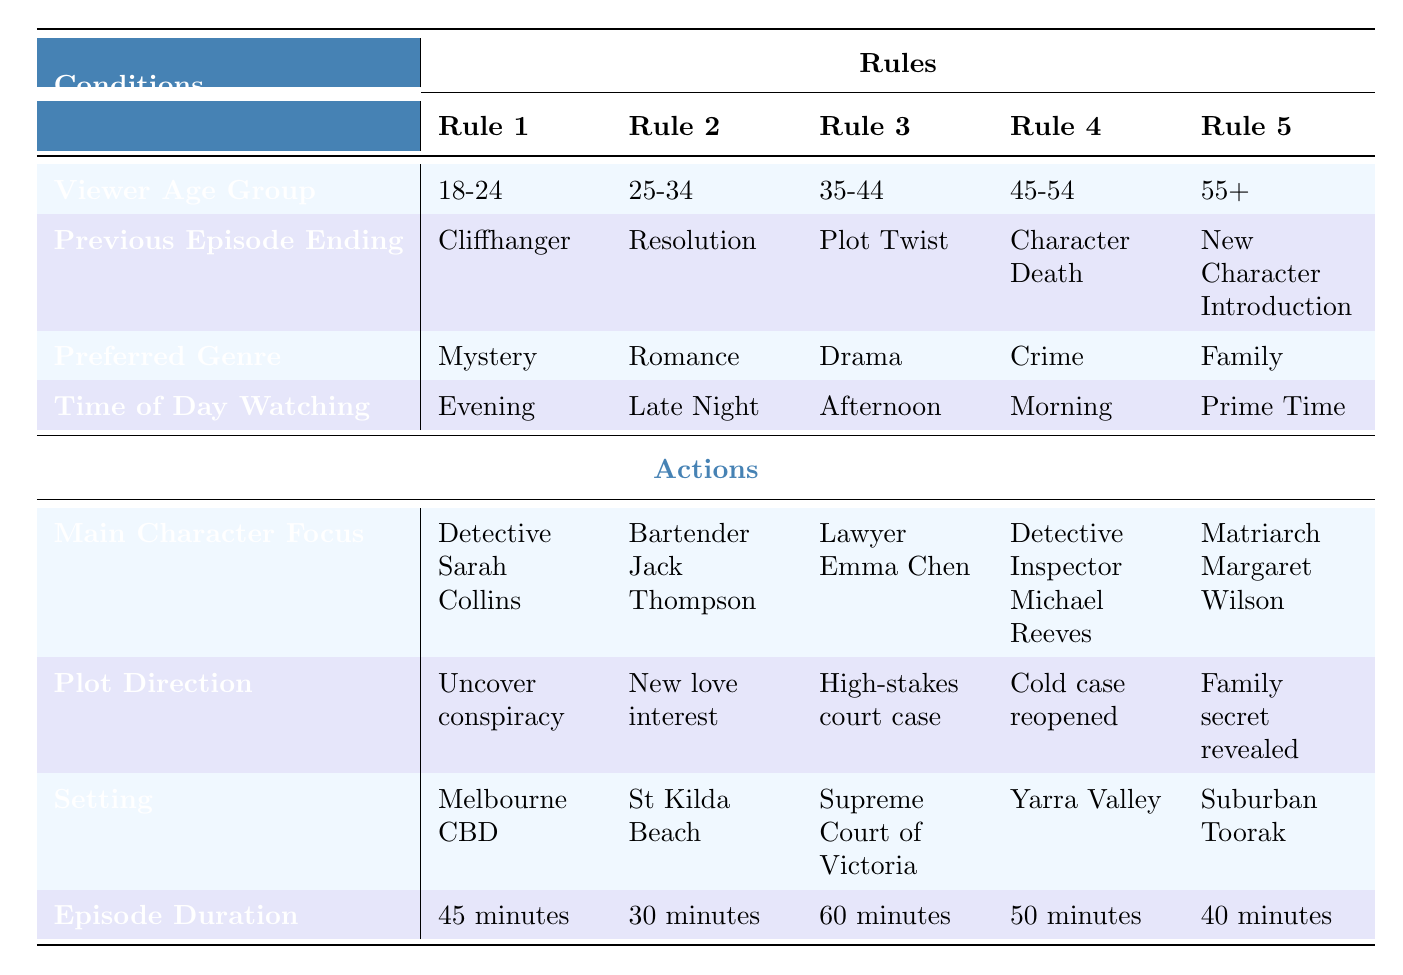What is the main character focus for the viewer age group 18-24? According to the table, for the viewer age group 18-24, the main character focus is "Detective Sarah Collins."
Answer: Detective Sarah Collins Which plot direction is associated with a previous episode ending of a cliffhanger? The plot direction associated with a cliffhanger ending is "Uncover conspiracy" as stated in the row corresponding to the cliffhanger.
Answer: Uncover conspiracy True or False: The episode duration for viewers aged 25-34 is 45 minutes. The episode duration for the viewer age group 25-34 is actually 30 minutes, as seen in the corresponding row. Therefore, the statement is false.
Answer: False What is the setting for the episode focused on Detective Inspector Michael Reeves? The setting for the episode focused on Detective Inspector Michael Reeves, who is in the viewer age group 45-54, is "Yarra Valley" as specified in the respective row of the table.
Answer: Yarra Valley If a viewer aged 55+ prefers family genre, what is the duration of that episode? The episode duration for the viewer age group 55+, who prefers the family genre, is 40 minutes as stated in the relevant row of the table.
Answer: 40 minutes Which viewer group has a plot direction of "High-stakes court case"? The viewer group that has a plot direction of "High-stakes court case" is aged 35-44, as indicated in that specific rule in the table.
Answer: 35-44 How many different main characters are listed in the table? There are five unique main characters listed in the table: Detective Sarah Collins, Bartender Jack Thompson, Lawyer Emma Chen, Detective Inspector Michael Reeves, and Matriarch Margaret Wilson. Counting them provides us with the total of 5 main characters.
Answer: 5 Is there a viewer group that has a morning viewing time with a detective as the main character? Yes, the viewer group aged 45-54 has a morning viewing time, and the main character is Detective Inspector Michael Reeves. This information can be verified by looking at the respective age group and viewing time.
Answer: Yes What episode duration is seen most frequently across the viewer age groups in the table? The various episode durations for the age groups are 45 minutes, 30 minutes, 60 minutes, 50 minutes, and 40 minutes. Since each duration is mentioned only once, there is no episode duration that occurs more frequently based on the conditions given.
Answer: None 